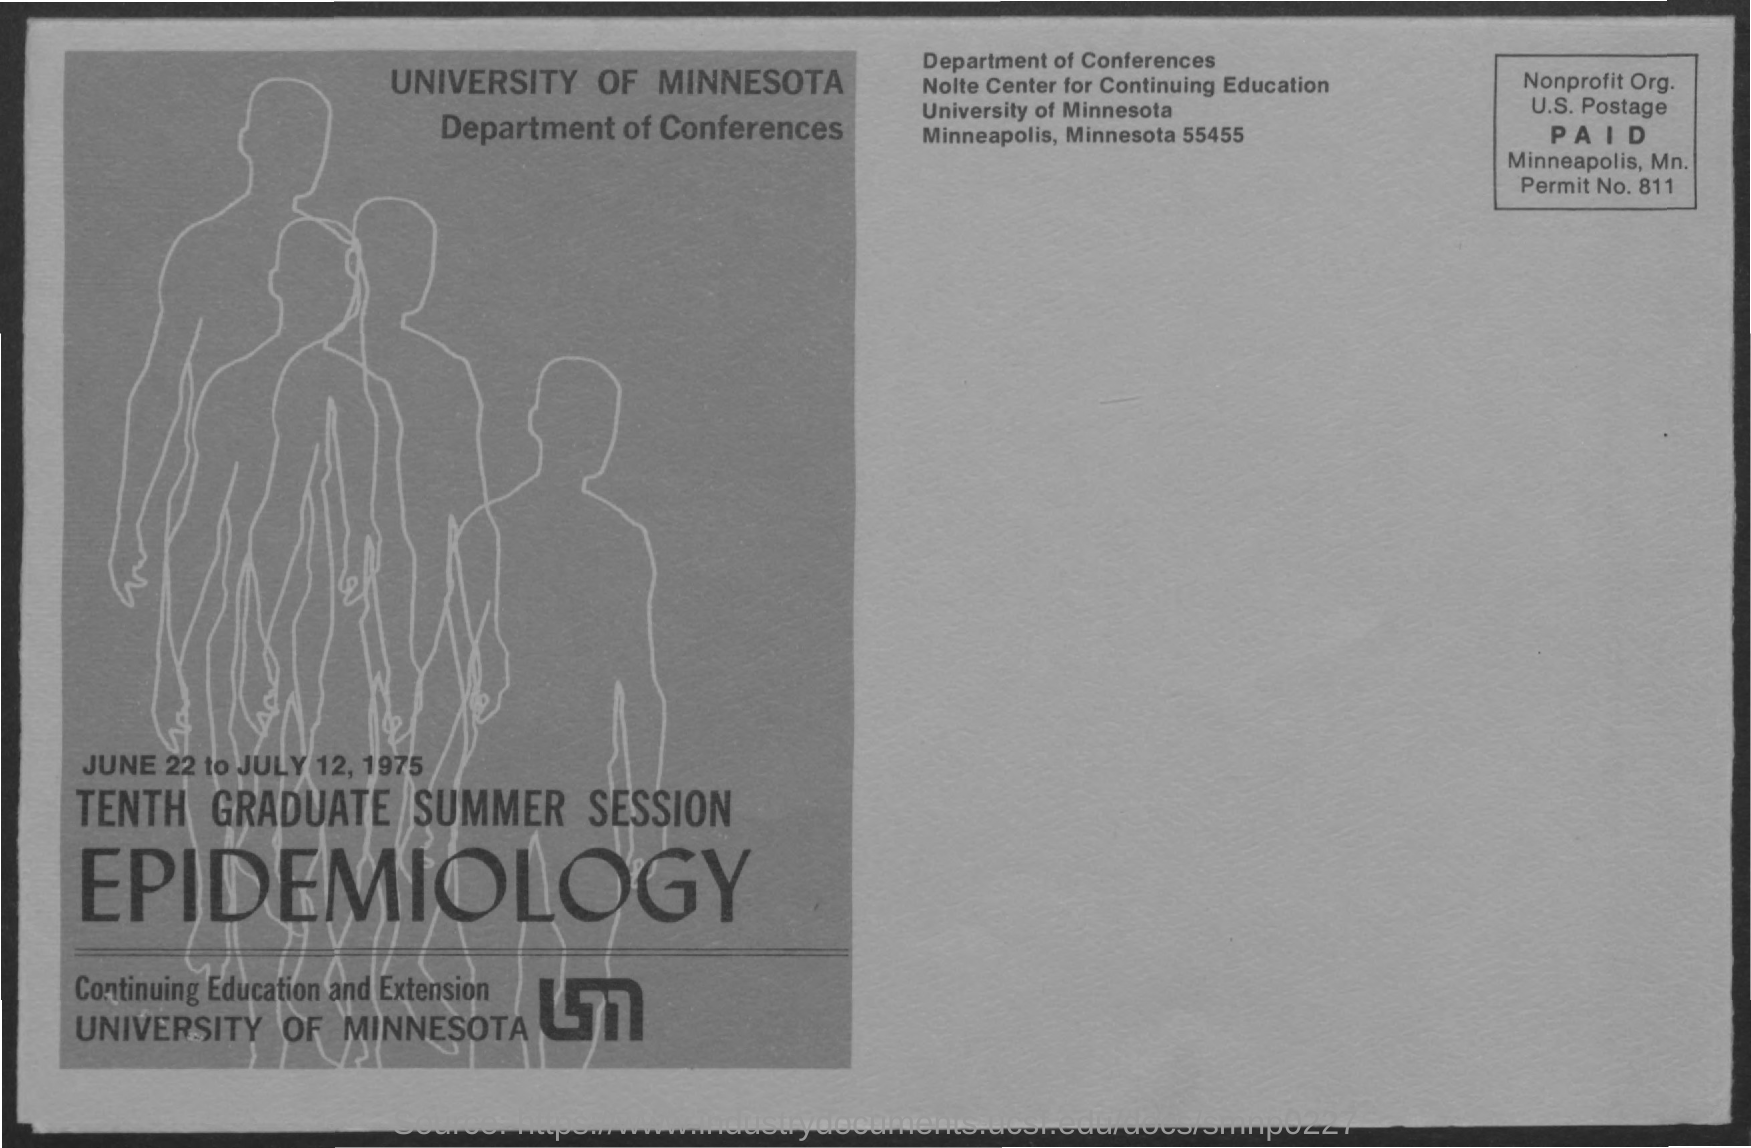What is the Permit No. Mentioned in this document?
Give a very brief answer. 811. Which University is conducting Tenth Graduate Summer Session Epidemiology?
Your response must be concise. University of minnesota. 